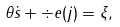<formula> <loc_0><loc_0><loc_500><loc_500>\theta \dot { s } + \div e ( j ) = \xi ,</formula> 